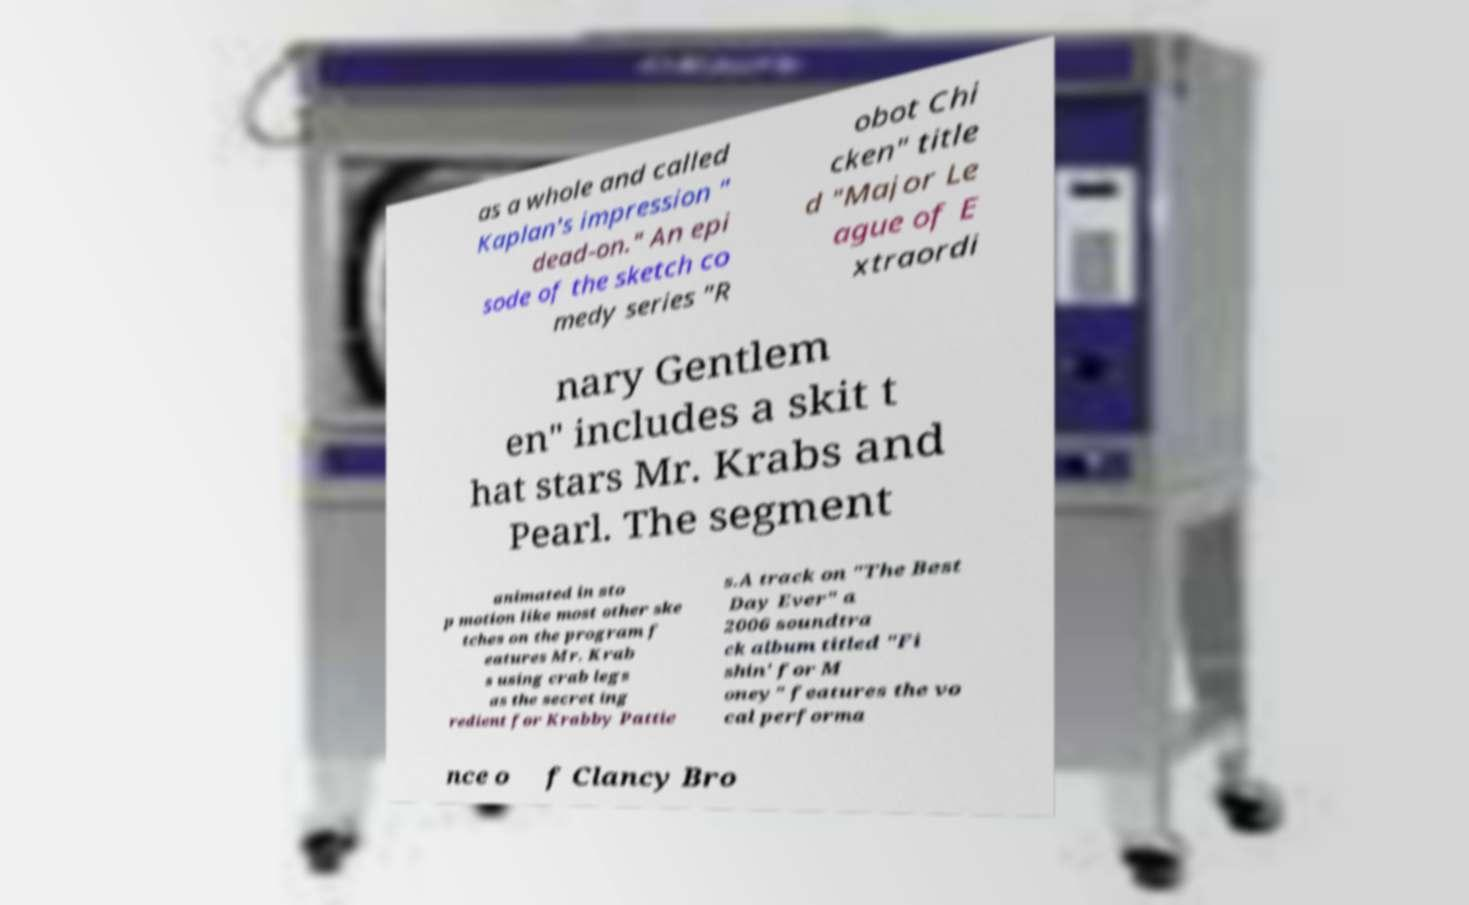Can you accurately transcribe the text from the provided image for me? as a whole and called Kaplan's impression " dead-on." An epi sode of the sketch co medy series "R obot Chi cken" title d "Major Le ague of E xtraordi nary Gentlem en" includes a skit t hat stars Mr. Krabs and Pearl. The segment animated in sto p motion like most other ske tches on the program f eatures Mr. Krab s using crab legs as the secret ing redient for Krabby Pattie s.A track on "The Best Day Ever" a 2006 soundtra ck album titled "Fi shin' for M oney" features the vo cal performa nce o f Clancy Bro 